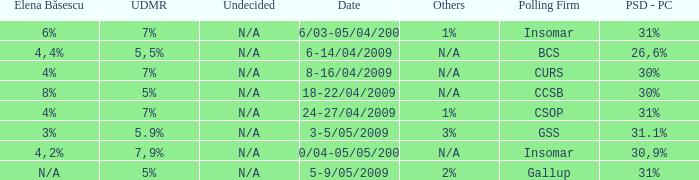What is the elena basescu when the poling firm of gallup? N/A. 